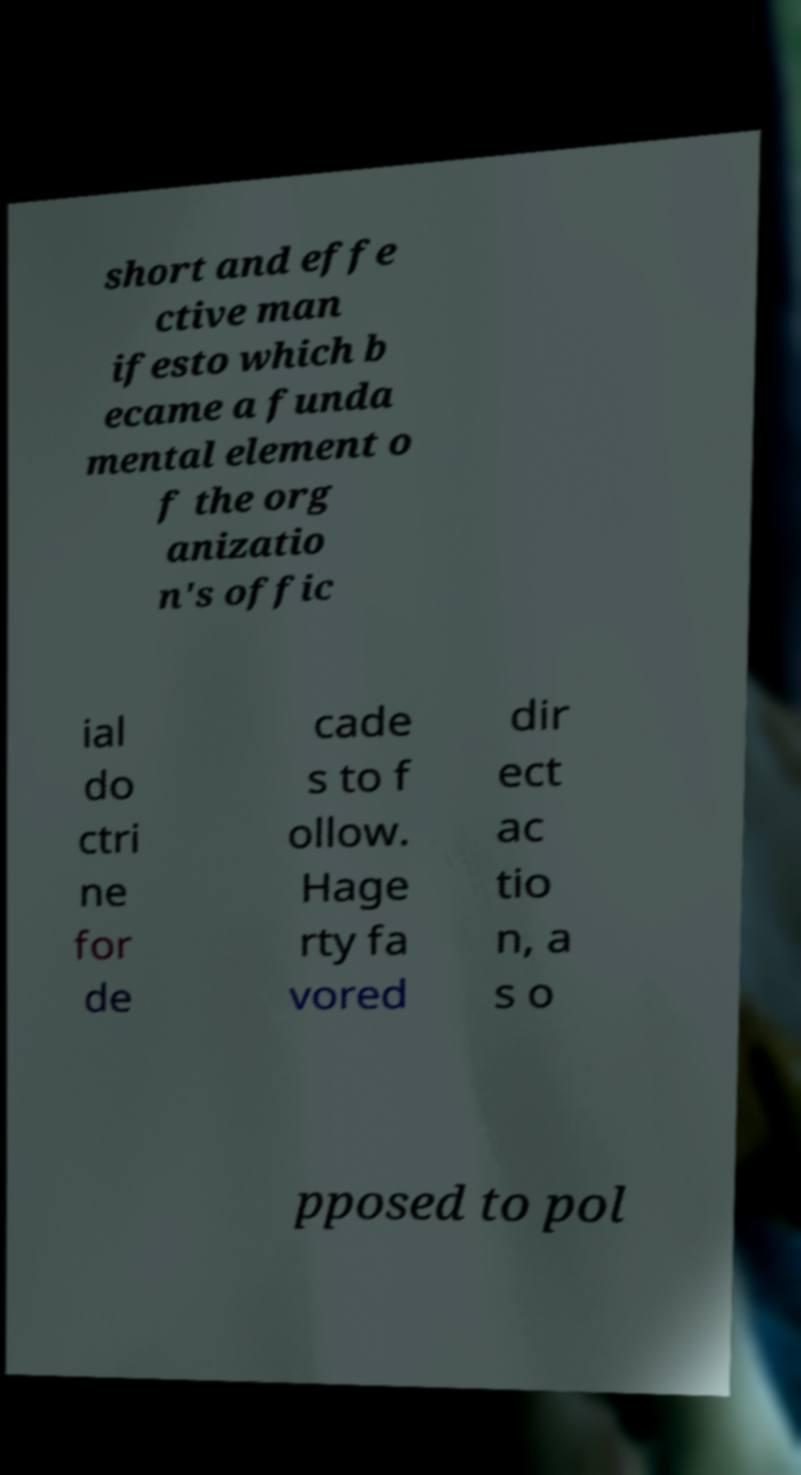Could you assist in decoding the text presented in this image and type it out clearly? short and effe ctive man ifesto which b ecame a funda mental element o f the org anizatio n's offic ial do ctri ne for de cade s to f ollow. Hage rty fa vored dir ect ac tio n, a s o pposed to pol 